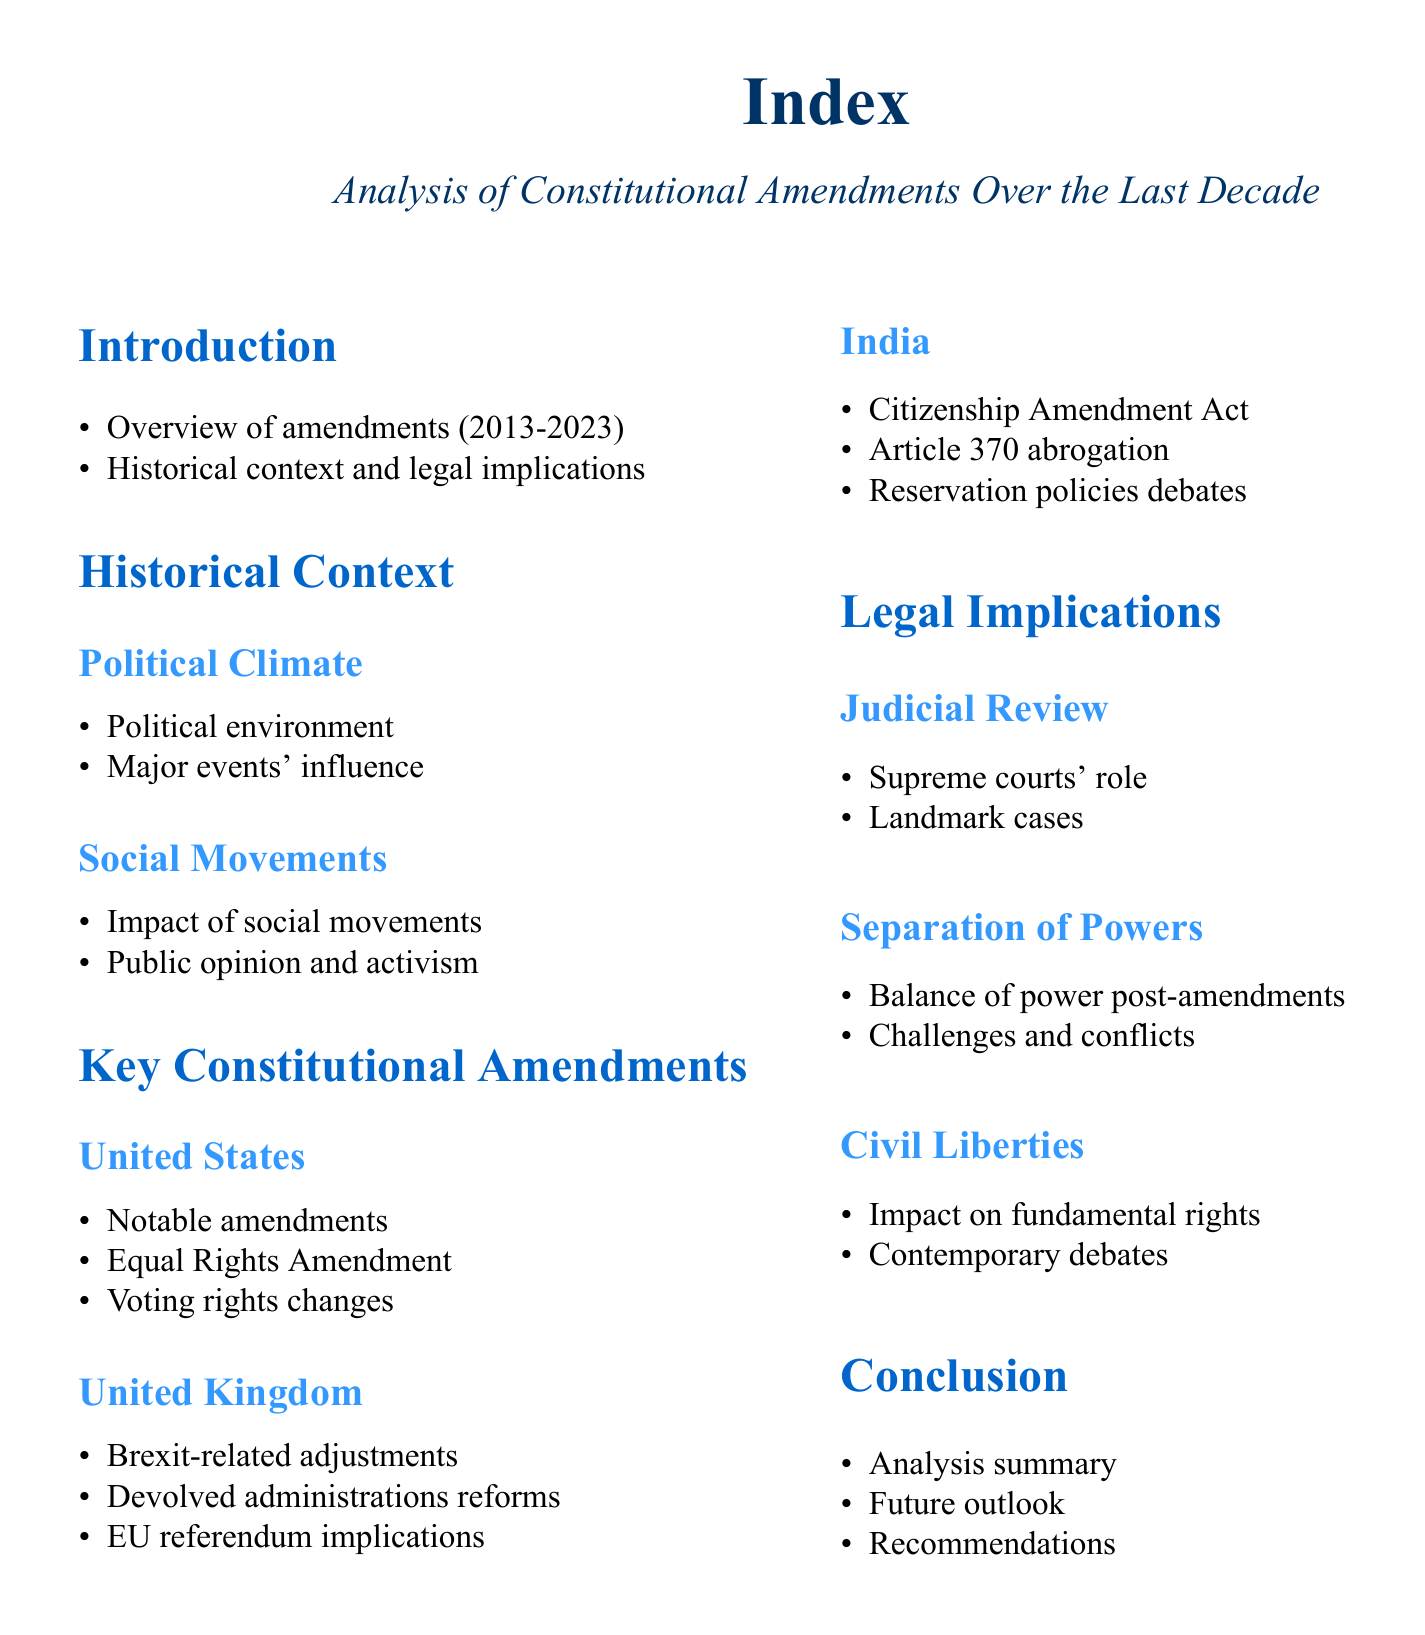What years are covered in the overview of amendments? The document states that the amendments reviewed are from 2013 to 2023.
Answer: 2013-2023 What is one major social movement mentioned? The document highlights the impact of social movements but does not specify one; however, they generally influence constitutional amendments.
Answer: Not specified Which amendment is noted under the United States section? The Equal Rights Amendment is mentioned as a notable amendment in the United States.
Answer: Equal Rights Amendment What significant act is discussed in India? The Citizenship Amendment Act is a key constitutional amendment referenced in the document concerning India.
Answer: Citizenship Amendment Act What role do supreme courts play according to the document? The role of the Supreme courts is discussed in the context of judicial review in the legal implications section.
Answer: Judicial Review What type of reforms are included in the United Kingdom section? The document refers to reforms related to devolved administrations under the United Kingdom section.
Answer: Devolved administrations reforms How many sections are there in the document? The document includes four main sections: Introduction, Historical Context, Key Constitutional Amendments, and Legal Implications.
Answer: Four What legal aspect does the conclusion summarize? The conclusion provides an analysis summary regarding the constitutional amendments over the last decade.
Answer: Analysis summary What are future recommendations about? The conclusion includes future outlook and recommendations related to constitutional amendments.
Answer: Recommendations 